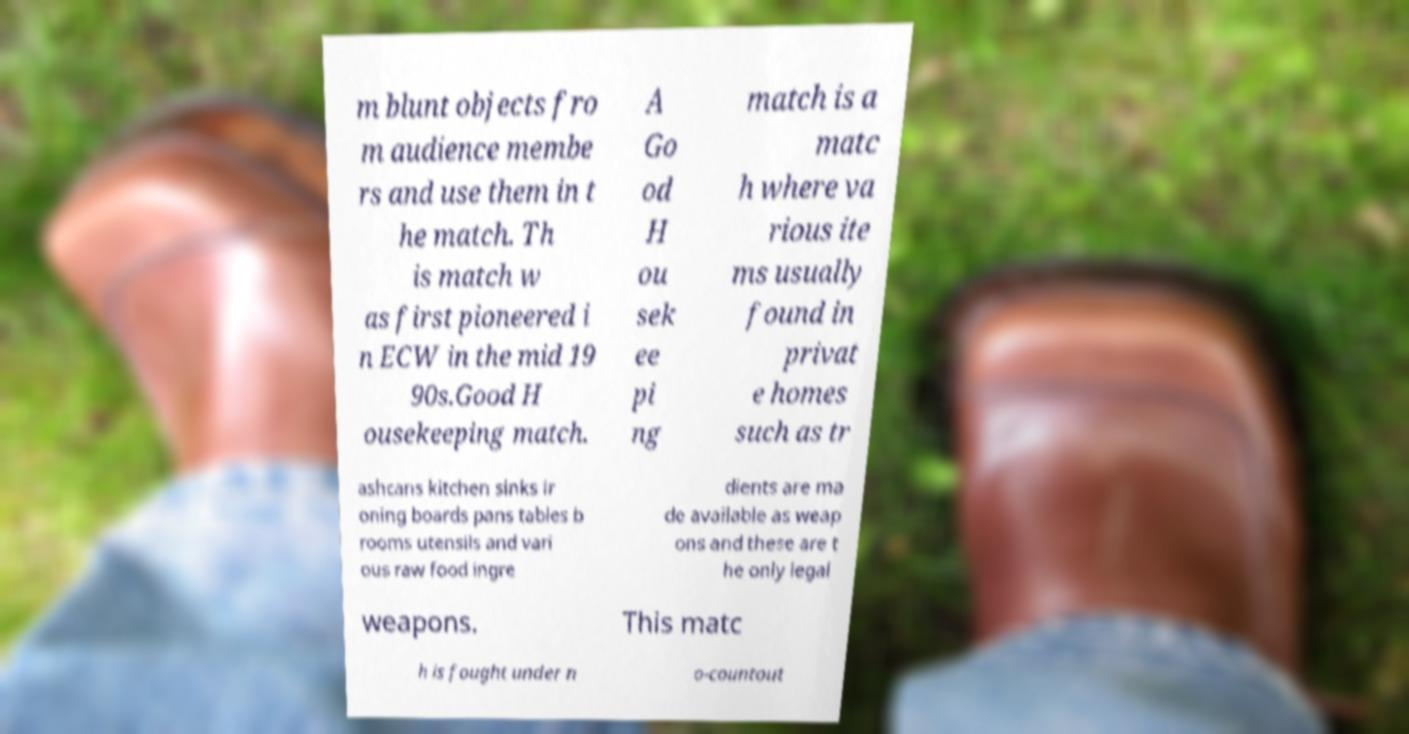Can you read and provide the text displayed in the image?This photo seems to have some interesting text. Can you extract and type it out for me? m blunt objects fro m audience membe rs and use them in t he match. Th is match w as first pioneered i n ECW in the mid 19 90s.Good H ousekeeping match. A Go od H ou sek ee pi ng match is a matc h where va rious ite ms usually found in privat e homes such as tr ashcans kitchen sinks ir oning boards pans tables b rooms utensils and vari ous raw food ingre dients are ma de available as weap ons and these are t he only legal weapons. This matc h is fought under n o-countout 